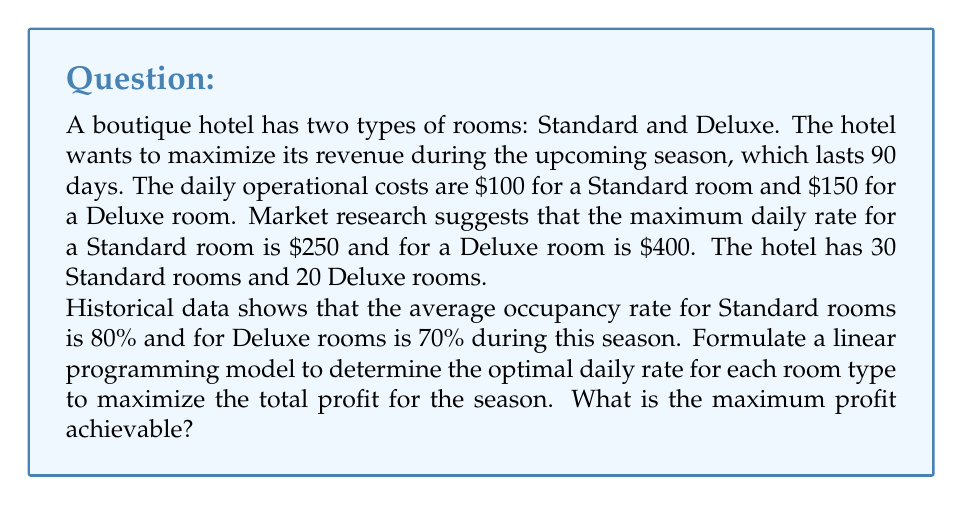Teach me how to tackle this problem. Let's approach this step-by-step:

1. Define variables:
   Let $x$ = daily rate for Standard room
   Let $y$ = daily rate for Deluxe room

2. Objective function:
   Maximize profit = Revenue - Costs
   $$Z = 90[(0.8 \cdot 30x - 100 \cdot 30) + (0.7 \cdot 20y - 150 \cdot 20)]$$

3. Constraints:
   a) Rates cannot exceed maximum:
      $x \leq 250$
      $y \leq 400$
   b) Rates must be non-negative:
      $x \geq 0$
      $y \geq 0$

4. Simplify the objective function:
   $$Z = 2160x + 1260y - 540000$$

5. The linear programming model:
   Maximize $Z = 2160x + 1260y - 540000$
   Subject to:
   $x \leq 250$
   $y \leq 400$
   $x \geq 0$
   $y \geq 0$

6. Solve using the corner point method:
   The optimal solution will be at one of these points:
   (0, 0), (250, 0), (0, 400), (250, 400)

7. Evaluate Z at each point:
   (0, 0): Z = -540000
   (250, 0): Z = 0
   (0, 400): Z = -36000
   (250, 400): Z = 504000

8. The maximum profit is achieved at (250, 400), which means setting the Standard room rate to $250 and the Deluxe room rate to $400.

9. Calculate the maximum profit:
   $$Z = 2160(250) + 1260(400) - 540000 = 504000$$

Therefore, the maximum profit achievable for the season is $504,000.
Answer: $504,000 